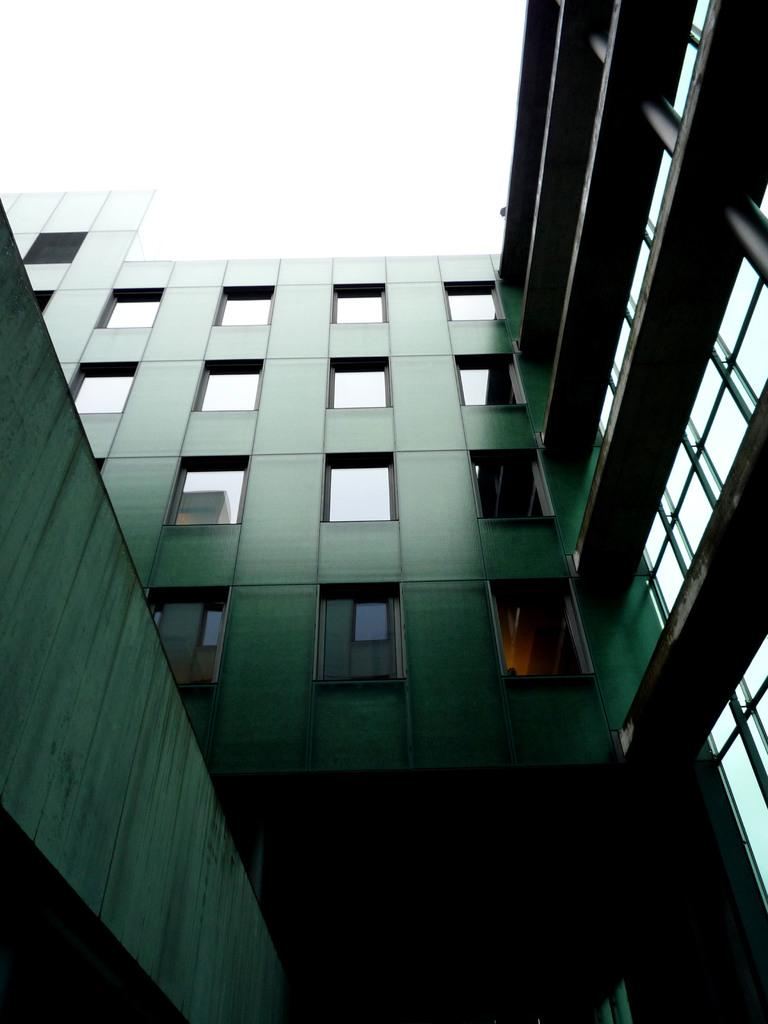What type of structure is present in the image? There is a building in the image. What is the color of the building? The building is green in color. What material is used in between the structure of the building? The building has glass in between its structure. Can you see any bees buzzing around the building in the image? There is no indication of bees or any other insects in the image. What type of rock is visible near the building in the image? There is no rock visible near the building in the image. 